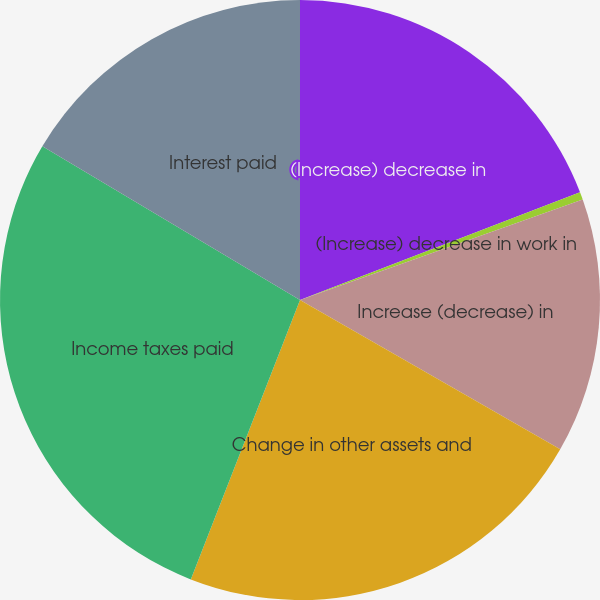Convert chart to OTSL. <chart><loc_0><loc_0><loc_500><loc_500><pie_chart><fcel>(Increase) decrease in<fcel>(Increase) decrease in work in<fcel>Increase (decrease) in<fcel>Change in other assets and<fcel>Income taxes paid<fcel>Interest paid<nl><fcel>19.16%<fcel>0.41%<fcel>13.72%<fcel>22.64%<fcel>27.63%<fcel>16.44%<nl></chart> 